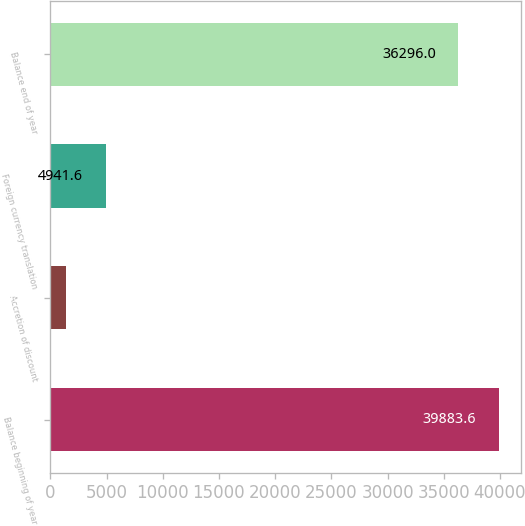Convert chart. <chart><loc_0><loc_0><loc_500><loc_500><bar_chart><fcel>Balance beginning of year<fcel>Accretion of discount<fcel>Foreign currency translation<fcel>Balance end of year<nl><fcel>39883.6<fcel>1354<fcel>4941.6<fcel>36296<nl></chart> 